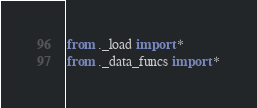<code> <loc_0><loc_0><loc_500><loc_500><_Python_>from ._load import *
from ._data_funcs import *
</code> 